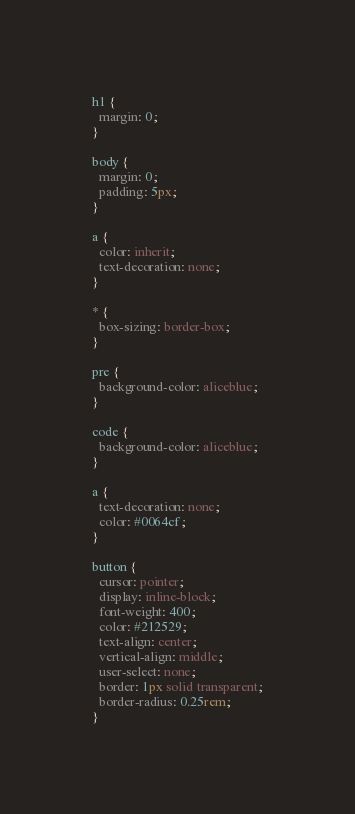Convert code to text. <code><loc_0><loc_0><loc_500><loc_500><_CSS_>
h1 {
  margin: 0;
}

body {
  margin: 0;
  padding: 5px;
}

a {
  color: inherit;
  text-decoration: none;
}

* {
  box-sizing: border-box;
}

pre {
  background-color: aliceblue;
}

code {
  background-color: aliceblue;
}

a {
  text-decoration: none;
  color: #0064cf;
}

button {
  cursor: pointer;
  display: inline-block;
  font-weight: 400;
  color: #212529;
  text-align: center;
  vertical-align: middle;
  user-select: none;
  border: 1px solid transparent;
  border-radius: 0.25rem;
}
</code> 